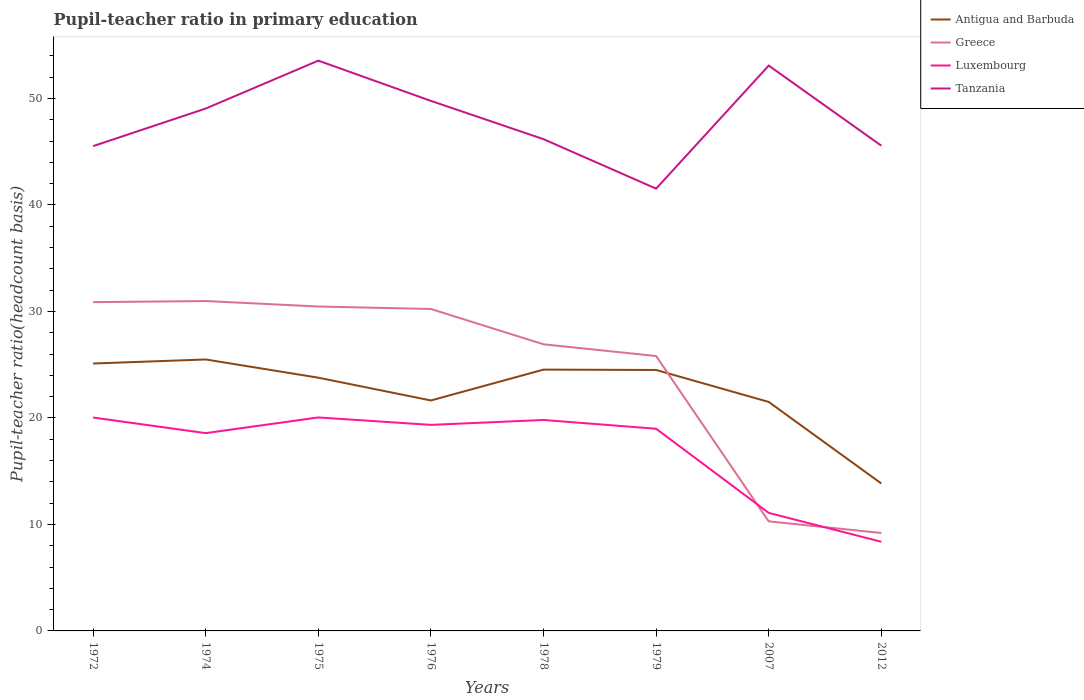Is the number of lines equal to the number of legend labels?
Your answer should be very brief. Yes. Across all years, what is the maximum pupil-teacher ratio in primary education in Greece?
Your answer should be very brief. 9.2. What is the total pupil-teacher ratio in primary education in Luxembourg in the graph?
Keep it short and to the point. 7.9. What is the difference between the highest and the second highest pupil-teacher ratio in primary education in Luxembourg?
Provide a short and direct response. 11.67. What is the difference between the highest and the lowest pupil-teacher ratio in primary education in Tanzania?
Your response must be concise. 4. How many lines are there?
Provide a succinct answer. 4. What is the difference between two consecutive major ticks on the Y-axis?
Offer a terse response. 10. Are the values on the major ticks of Y-axis written in scientific E-notation?
Your answer should be very brief. No. Does the graph contain any zero values?
Provide a succinct answer. No. How many legend labels are there?
Offer a terse response. 4. How are the legend labels stacked?
Provide a succinct answer. Vertical. What is the title of the graph?
Make the answer very short. Pupil-teacher ratio in primary education. Does "Timor-Leste" appear as one of the legend labels in the graph?
Your answer should be compact. No. What is the label or title of the Y-axis?
Offer a very short reply. Pupil-teacher ratio(headcount basis). What is the Pupil-teacher ratio(headcount basis) in Antigua and Barbuda in 1972?
Provide a succinct answer. 25.11. What is the Pupil-teacher ratio(headcount basis) in Greece in 1972?
Offer a terse response. 30.87. What is the Pupil-teacher ratio(headcount basis) in Luxembourg in 1972?
Provide a short and direct response. 20.04. What is the Pupil-teacher ratio(headcount basis) in Tanzania in 1972?
Keep it short and to the point. 45.53. What is the Pupil-teacher ratio(headcount basis) in Antigua and Barbuda in 1974?
Keep it short and to the point. 25.49. What is the Pupil-teacher ratio(headcount basis) of Greece in 1974?
Provide a succinct answer. 30.98. What is the Pupil-teacher ratio(headcount basis) in Luxembourg in 1974?
Provide a succinct answer. 18.57. What is the Pupil-teacher ratio(headcount basis) of Tanzania in 1974?
Ensure brevity in your answer.  49.05. What is the Pupil-teacher ratio(headcount basis) in Antigua and Barbuda in 1975?
Make the answer very short. 23.78. What is the Pupil-teacher ratio(headcount basis) of Greece in 1975?
Offer a terse response. 30.46. What is the Pupil-teacher ratio(headcount basis) in Luxembourg in 1975?
Offer a very short reply. 20.05. What is the Pupil-teacher ratio(headcount basis) of Tanzania in 1975?
Your answer should be very brief. 53.55. What is the Pupil-teacher ratio(headcount basis) in Antigua and Barbuda in 1976?
Ensure brevity in your answer.  21.64. What is the Pupil-teacher ratio(headcount basis) in Greece in 1976?
Offer a very short reply. 30.23. What is the Pupil-teacher ratio(headcount basis) in Luxembourg in 1976?
Keep it short and to the point. 19.35. What is the Pupil-teacher ratio(headcount basis) of Tanzania in 1976?
Provide a succinct answer. 49.77. What is the Pupil-teacher ratio(headcount basis) in Antigua and Barbuda in 1978?
Give a very brief answer. 24.54. What is the Pupil-teacher ratio(headcount basis) in Greece in 1978?
Provide a succinct answer. 26.91. What is the Pupil-teacher ratio(headcount basis) of Luxembourg in 1978?
Your response must be concise. 19.81. What is the Pupil-teacher ratio(headcount basis) in Tanzania in 1978?
Keep it short and to the point. 46.18. What is the Pupil-teacher ratio(headcount basis) of Antigua and Barbuda in 1979?
Offer a very short reply. 24.51. What is the Pupil-teacher ratio(headcount basis) of Greece in 1979?
Your response must be concise. 25.81. What is the Pupil-teacher ratio(headcount basis) in Luxembourg in 1979?
Offer a very short reply. 18.99. What is the Pupil-teacher ratio(headcount basis) in Tanzania in 1979?
Keep it short and to the point. 41.53. What is the Pupil-teacher ratio(headcount basis) of Antigua and Barbuda in 2007?
Ensure brevity in your answer.  21.5. What is the Pupil-teacher ratio(headcount basis) of Greece in 2007?
Ensure brevity in your answer.  10.29. What is the Pupil-teacher ratio(headcount basis) in Luxembourg in 2007?
Make the answer very short. 11.08. What is the Pupil-teacher ratio(headcount basis) in Tanzania in 2007?
Ensure brevity in your answer.  53.09. What is the Pupil-teacher ratio(headcount basis) of Antigua and Barbuda in 2012?
Your answer should be very brief. 13.85. What is the Pupil-teacher ratio(headcount basis) in Greece in 2012?
Keep it short and to the point. 9.2. What is the Pupil-teacher ratio(headcount basis) in Luxembourg in 2012?
Your response must be concise. 8.37. What is the Pupil-teacher ratio(headcount basis) in Tanzania in 2012?
Provide a short and direct response. 45.57. Across all years, what is the maximum Pupil-teacher ratio(headcount basis) in Antigua and Barbuda?
Offer a terse response. 25.49. Across all years, what is the maximum Pupil-teacher ratio(headcount basis) in Greece?
Ensure brevity in your answer.  30.98. Across all years, what is the maximum Pupil-teacher ratio(headcount basis) of Luxembourg?
Offer a terse response. 20.05. Across all years, what is the maximum Pupil-teacher ratio(headcount basis) of Tanzania?
Your response must be concise. 53.55. Across all years, what is the minimum Pupil-teacher ratio(headcount basis) in Antigua and Barbuda?
Offer a very short reply. 13.85. Across all years, what is the minimum Pupil-teacher ratio(headcount basis) in Greece?
Offer a terse response. 9.2. Across all years, what is the minimum Pupil-teacher ratio(headcount basis) in Luxembourg?
Offer a very short reply. 8.37. Across all years, what is the minimum Pupil-teacher ratio(headcount basis) of Tanzania?
Provide a short and direct response. 41.53. What is the total Pupil-teacher ratio(headcount basis) in Antigua and Barbuda in the graph?
Make the answer very short. 180.42. What is the total Pupil-teacher ratio(headcount basis) of Greece in the graph?
Offer a terse response. 194.76. What is the total Pupil-teacher ratio(headcount basis) of Luxembourg in the graph?
Offer a very short reply. 136.26. What is the total Pupil-teacher ratio(headcount basis) of Tanzania in the graph?
Your answer should be very brief. 384.27. What is the difference between the Pupil-teacher ratio(headcount basis) in Antigua and Barbuda in 1972 and that in 1974?
Ensure brevity in your answer.  -0.38. What is the difference between the Pupil-teacher ratio(headcount basis) in Greece in 1972 and that in 1974?
Your response must be concise. -0.1. What is the difference between the Pupil-teacher ratio(headcount basis) of Luxembourg in 1972 and that in 1974?
Your answer should be compact. 1.47. What is the difference between the Pupil-teacher ratio(headcount basis) of Tanzania in 1972 and that in 1974?
Offer a very short reply. -3.53. What is the difference between the Pupil-teacher ratio(headcount basis) of Antigua and Barbuda in 1972 and that in 1975?
Keep it short and to the point. 1.33. What is the difference between the Pupil-teacher ratio(headcount basis) in Greece in 1972 and that in 1975?
Offer a terse response. 0.41. What is the difference between the Pupil-teacher ratio(headcount basis) of Luxembourg in 1972 and that in 1975?
Offer a very short reply. -0.01. What is the difference between the Pupil-teacher ratio(headcount basis) in Tanzania in 1972 and that in 1975?
Make the answer very short. -8.03. What is the difference between the Pupil-teacher ratio(headcount basis) in Antigua and Barbuda in 1972 and that in 1976?
Make the answer very short. 3.47. What is the difference between the Pupil-teacher ratio(headcount basis) in Greece in 1972 and that in 1976?
Keep it short and to the point. 0.64. What is the difference between the Pupil-teacher ratio(headcount basis) in Luxembourg in 1972 and that in 1976?
Offer a very short reply. 0.69. What is the difference between the Pupil-teacher ratio(headcount basis) in Tanzania in 1972 and that in 1976?
Ensure brevity in your answer.  -4.25. What is the difference between the Pupil-teacher ratio(headcount basis) in Antigua and Barbuda in 1972 and that in 1978?
Provide a short and direct response. 0.57. What is the difference between the Pupil-teacher ratio(headcount basis) in Greece in 1972 and that in 1978?
Ensure brevity in your answer.  3.96. What is the difference between the Pupil-teacher ratio(headcount basis) in Luxembourg in 1972 and that in 1978?
Your response must be concise. 0.23. What is the difference between the Pupil-teacher ratio(headcount basis) of Tanzania in 1972 and that in 1978?
Provide a succinct answer. -0.65. What is the difference between the Pupil-teacher ratio(headcount basis) of Antigua and Barbuda in 1972 and that in 1979?
Your answer should be very brief. 0.6. What is the difference between the Pupil-teacher ratio(headcount basis) of Greece in 1972 and that in 1979?
Offer a very short reply. 5.06. What is the difference between the Pupil-teacher ratio(headcount basis) in Luxembourg in 1972 and that in 1979?
Provide a succinct answer. 1.05. What is the difference between the Pupil-teacher ratio(headcount basis) in Tanzania in 1972 and that in 1979?
Provide a succinct answer. 3.99. What is the difference between the Pupil-teacher ratio(headcount basis) of Antigua and Barbuda in 1972 and that in 2007?
Keep it short and to the point. 3.61. What is the difference between the Pupil-teacher ratio(headcount basis) of Greece in 1972 and that in 2007?
Your response must be concise. 20.59. What is the difference between the Pupil-teacher ratio(headcount basis) in Luxembourg in 1972 and that in 2007?
Provide a succinct answer. 8.96. What is the difference between the Pupil-teacher ratio(headcount basis) in Tanzania in 1972 and that in 2007?
Your answer should be very brief. -7.56. What is the difference between the Pupil-teacher ratio(headcount basis) in Antigua and Barbuda in 1972 and that in 2012?
Ensure brevity in your answer.  11.27. What is the difference between the Pupil-teacher ratio(headcount basis) in Greece in 1972 and that in 2012?
Offer a very short reply. 21.68. What is the difference between the Pupil-teacher ratio(headcount basis) of Luxembourg in 1972 and that in 2012?
Make the answer very short. 11.67. What is the difference between the Pupil-teacher ratio(headcount basis) in Tanzania in 1972 and that in 2012?
Your answer should be compact. -0.04. What is the difference between the Pupil-teacher ratio(headcount basis) in Antigua and Barbuda in 1974 and that in 1975?
Offer a terse response. 1.71. What is the difference between the Pupil-teacher ratio(headcount basis) of Greece in 1974 and that in 1975?
Keep it short and to the point. 0.51. What is the difference between the Pupil-teacher ratio(headcount basis) of Luxembourg in 1974 and that in 1975?
Provide a short and direct response. -1.47. What is the difference between the Pupil-teacher ratio(headcount basis) in Tanzania in 1974 and that in 1975?
Make the answer very short. -4.5. What is the difference between the Pupil-teacher ratio(headcount basis) in Antigua and Barbuda in 1974 and that in 1976?
Provide a succinct answer. 3.85. What is the difference between the Pupil-teacher ratio(headcount basis) of Greece in 1974 and that in 1976?
Your answer should be compact. 0.75. What is the difference between the Pupil-teacher ratio(headcount basis) of Luxembourg in 1974 and that in 1976?
Your answer should be compact. -0.78. What is the difference between the Pupil-teacher ratio(headcount basis) in Tanzania in 1974 and that in 1976?
Ensure brevity in your answer.  -0.72. What is the difference between the Pupil-teacher ratio(headcount basis) of Antigua and Barbuda in 1974 and that in 1978?
Make the answer very short. 0.95. What is the difference between the Pupil-teacher ratio(headcount basis) of Greece in 1974 and that in 1978?
Provide a short and direct response. 4.06. What is the difference between the Pupil-teacher ratio(headcount basis) in Luxembourg in 1974 and that in 1978?
Give a very brief answer. -1.24. What is the difference between the Pupil-teacher ratio(headcount basis) in Tanzania in 1974 and that in 1978?
Give a very brief answer. 2.88. What is the difference between the Pupil-teacher ratio(headcount basis) of Antigua and Barbuda in 1974 and that in 1979?
Your answer should be very brief. 0.99. What is the difference between the Pupil-teacher ratio(headcount basis) in Greece in 1974 and that in 1979?
Your response must be concise. 5.17. What is the difference between the Pupil-teacher ratio(headcount basis) in Luxembourg in 1974 and that in 1979?
Your response must be concise. -0.41. What is the difference between the Pupil-teacher ratio(headcount basis) of Tanzania in 1974 and that in 1979?
Your response must be concise. 7.52. What is the difference between the Pupil-teacher ratio(headcount basis) in Antigua and Barbuda in 1974 and that in 2007?
Your answer should be compact. 3.99. What is the difference between the Pupil-teacher ratio(headcount basis) in Greece in 1974 and that in 2007?
Give a very brief answer. 20.69. What is the difference between the Pupil-teacher ratio(headcount basis) in Luxembourg in 1974 and that in 2007?
Your response must be concise. 7.49. What is the difference between the Pupil-teacher ratio(headcount basis) of Tanzania in 1974 and that in 2007?
Keep it short and to the point. -4.03. What is the difference between the Pupil-teacher ratio(headcount basis) of Antigua and Barbuda in 1974 and that in 2012?
Provide a succinct answer. 11.65. What is the difference between the Pupil-teacher ratio(headcount basis) in Greece in 1974 and that in 2012?
Offer a terse response. 21.78. What is the difference between the Pupil-teacher ratio(headcount basis) in Luxembourg in 1974 and that in 2012?
Give a very brief answer. 10.2. What is the difference between the Pupil-teacher ratio(headcount basis) in Tanzania in 1974 and that in 2012?
Give a very brief answer. 3.49. What is the difference between the Pupil-teacher ratio(headcount basis) of Antigua and Barbuda in 1975 and that in 1976?
Offer a very short reply. 2.14. What is the difference between the Pupil-teacher ratio(headcount basis) of Greece in 1975 and that in 1976?
Offer a terse response. 0.23. What is the difference between the Pupil-teacher ratio(headcount basis) in Luxembourg in 1975 and that in 1976?
Your answer should be very brief. 0.7. What is the difference between the Pupil-teacher ratio(headcount basis) of Tanzania in 1975 and that in 1976?
Provide a succinct answer. 3.78. What is the difference between the Pupil-teacher ratio(headcount basis) of Antigua and Barbuda in 1975 and that in 1978?
Your answer should be very brief. -0.76. What is the difference between the Pupil-teacher ratio(headcount basis) of Greece in 1975 and that in 1978?
Provide a succinct answer. 3.55. What is the difference between the Pupil-teacher ratio(headcount basis) of Luxembourg in 1975 and that in 1978?
Give a very brief answer. 0.24. What is the difference between the Pupil-teacher ratio(headcount basis) in Tanzania in 1975 and that in 1978?
Your response must be concise. 7.37. What is the difference between the Pupil-teacher ratio(headcount basis) in Antigua and Barbuda in 1975 and that in 1979?
Offer a very short reply. -0.72. What is the difference between the Pupil-teacher ratio(headcount basis) in Greece in 1975 and that in 1979?
Keep it short and to the point. 4.65. What is the difference between the Pupil-teacher ratio(headcount basis) in Luxembourg in 1975 and that in 1979?
Keep it short and to the point. 1.06. What is the difference between the Pupil-teacher ratio(headcount basis) of Tanzania in 1975 and that in 1979?
Give a very brief answer. 12.02. What is the difference between the Pupil-teacher ratio(headcount basis) of Antigua and Barbuda in 1975 and that in 2007?
Give a very brief answer. 2.28. What is the difference between the Pupil-teacher ratio(headcount basis) in Greece in 1975 and that in 2007?
Your answer should be very brief. 20.17. What is the difference between the Pupil-teacher ratio(headcount basis) in Luxembourg in 1975 and that in 2007?
Your response must be concise. 8.96. What is the difference between the Pupil-teacher ratio(headcount basis) in Tanzania in 1975 and that in 2007?
Your answer should be compact. 0.47. What is the difference between the Pupil-teacher ratio(headcount basis) of Antigua and Barbuda in 1975 and that in 2012?
Ensure brevity in your answer.  9.94. What is the difference between the Pupil-teacher ratio(headcount basis) of Greece in 1975 and that in 2012?
Your answer should be compact. 21.27. What is the difference between the Pupil-teacher ratio(headcount basis) in Luxembourg in 1975 and that in 2012?
Provide a succinct answer. 11.67. What is the difference between the Pupil-teacher ratio(headcount basis) of Tanzania in 1975 and that in 2012?
Your answer should be compact. 7.99. What is the difference between the Pupil-teacher ratio(headcount basis) of Antigua and Barbuda in 1976 and that in 1978?
Your answer should be compact. -2.9. What is the difference between the Pupil-teacher ratio(headcount basis) of Greece in 1976 and that in 1978?
Provide a short and direct response. 3.32. What is the difference between the Pupil-teacher ratio(headcount basis) of Luxembourg in 1976 and that in 1978?
Your answer should be compact. -0.46. What is the difference between the Pupil-teacher ratio(headcount basis) of Tanzania in 1976 and that in 1978?
Ensure brevity in your answer.  3.59. What is the difference between the Pupil-teacher ratio(headcount basis) in Antigua and Barbuda in 1976 and that in 1979?
Ensure brevity in your answer.  -2.86. What is the difference between the Pupil-teacher ratio(headcount basis) in Greece in 1976 and that in 1979?
Your response must be concise. 4.42. What is the difference between the Pupil-teacher ratio(headcount basis) in Luxembourg in 1976 and that in 1979?
Provide a short and direct response. 0.36. What is the difference between the Pupil-teacher ratio(headcount basis) of Tanzania in 1976 and that in 1979?
Ensure brevity in your answer.  8.24. What is the difference between the Pupil-teacher ratio(headcount basis) in Antigua and Barbuda in 1976 and that in 2007?
Provide a short and direct response. 0.14. What is the difference between the Pupil-teacher ratio(headcount basis) of Greece in 1976 and that in 2007?
Give a very brief answer. 19.94. What is the difference between the Pupil-teacher ratio(headcount basis) in Luxembourg in 1976 and that in 2007?
Provide a succinct answer. 8.27. What is the difference between the Pupil-teacher ratio(headcount basis) of Tanzania in 1976 and that in 2007?
Offer a terse response. -3.31. What is the difference between the Pupil-teacher ratio(headcount basis) in Antigua and Barbuda in 1976 and that in 2012?
Your answer should be compact. 7.8. What is the difference between the Pupil-teacher ratio(headcount basis) of Greece in 1976 and that in 2012?
Provide a short and direct response. 21.03. What is the difference between the Pupil-teacher ratio(headcount basis) of Luxembourg in 1976 and that in 2012?
Make the answer very short. 10.98. What is the difference between the Pupil-teacher ratio(headcount basis) in Tanzania in 1976 and that in 2012?
Offer a very short reply. 4.21. What is the difference between the Pupil-teacher ratio(headcount basis) in Antigua and Barbuda in 1978 and that in 1979?
Your answer should be compact. 0.03. What is the difference between the Pupil-teacher ratio(headcount basis) in Greece in 1978 and that in 1979?
Your answer should be very brief. 1.1. What is the difference between the Pupil-teacher ratio(headcount basis) in Luxembourg in 1978 and that in 1979?
Your answer should be very brief. 0.82. What is the difference between the Pupil-teacher ratio(headcount basis) in Tanzania in 1978 and that in 1979?
Give a very brief answer. 4.65. What is the difference between the Pupil-teacher ratio(headcount basis) of Antigua and Barbuda in 1978 and that in 2007?
Provide a short and direct response. 3.03. What is the difference between the Pupil-teacher ratio(headcount basis) in Greece in 1978 and that in 2007?
Offer a very short reply. 16.63. What is the difference between the Pupil-teacher ratio(headcount basis) in Luxembourg in 1978 and that in 2007?
Your answer should be very brief. 8.72. What is the difference between the Pupil-teacher ratio(headcount basis) in Tanzania in 1978 and that in 2007?
Provide a short and direct response. -6.91. What is the difference between the Pupil-teacher ratio(headcount basis) in Antigua and Barbuda in 1978 and that in 2012?
Your answer should be very brief. 10.69. What is the difference between the Pupil-teacher ratio(headcount basis) in Greece in 1978 and that in 2012?
Provide a short and direct response. 17.72. What is the difference between the Pupil-teacher ratio(headcount basis) in Luxembourg in 1978 and that in 2012?
Ensure brevity in your answer.  11.44. What is the difference between the Pupil-teacher ratio(headcount basis) of Tanzania in 1978 and that in 2012?
Offer a terse response. 0.61. What is the difference between the Pupil-teacher ratio(headcount basis) in Antigua and Barbuda in 1979 and that in 2007?
Provide a succinct answer. 3. What is the difference between the Pupil-teacher ratio(headcount basis) of Greece in 1979 and that in 2007?
Offer a terse response. 15.52. What is the difference between the Pupil-teacher ratio(headcount basis) in Luxembourg in 1979 and that in 2007?
Your response must be concise. 7.9. What is the difference between the Pupil-teacher ratio(headcount basis) of Tanzania in 1979 and that in 2007?
Keep it short and to the point. -11.56. What is the difference between the Pupil-teacher ratio(headcount basis) of Antigua and Barbuda in 1979 and that in 2012?
Provide a short and direct response. 10.66. What is the difference between the Pupil-teacher ratio(headcount basis) of Greece in 1979 and that in 2012?
Ensure brevity in your answer.  16.61. What is the difference between the Pupil-teacher ratio(headcount basis) of Luxembourg in 1979 and that in 2012?
Provide a short and direct response. 10.61. What is the difference between the Pupil-teacher ratio(headcount basis) in Tanzania in 1979 and that in 2012?
Make the answer very short. -4.04. What is the difference between the Pupil-teacher ratio(headcount basis) in Antigua and Barbuda in 2007 and that in 2012?
Offer a terse response. 7.66. What is the difference between the Pupil-teacher ratio(headcount basis) of Greece in 2007 and that in 2012?
Provide a succinct answer. 1.09. What is the difference between the Pupil-teacher ratio(headcount basis) in Luxembourg in 2007 and that in 2012?
Offer a terse response. 2.71. What is the difference between the Pupil-teacher ratio(headcount basis) in Tanzania in 2007 and that in 2012?
Make the answer very short. 7.52. What is the difference between the Pupil-teacher ratio(headcount basis) of Antigua and Barbuda in 1972 and the Pupil-teacher ratio(headcount basis) of Greece in 1974?
Your answer should be very brief. -5.87. What is the difference between the Pupil-teacher ratio(headcount basis) of Antigua and Barbuda in 1972 and the Pupil-teacher ratio(headcount basis) of Luxembourg in 1974?
Give a very brief answer. 6.54. What is the difference between the Pupil-teacher ratio(headcount basis) of Antigua and Barbuda in 1972 and the Pupil-teacher ratio(headcount basis) of Tanzania in 1974?
Offer a very short reply. -23.94. What is the difference between the Pupil-teacher ratio(headcount basis) of Greece in 1972 and the Pupil-teacher ratio(headcount basis) of Luxembourg in 1974?
Give a very brief answer. 12.3. What is the difference between the Pupil-teacher ratio(headcount basis) of Greece in 1972 and the Pupil-teacher ratio(headcount basis) of Tanzania in 1974?
Provide a succinct answer. -18.18. What is the difference between the Pupil-teacher ratio(headcount basis) in Luxembourg in 1972 and the Pupil-teacher ratio(headcount basis) in Tanzania in 1974?
Keep it short and to the point. -29.02. What is the difference between the Pupil-teacher ratio(headcount basis) in Antigua and Barbuda in 1972 and the Pupil-teacher ratio(headcount basis) in Greece in 1975?
Provide a succinct answer. -5.35. What is the difference between the Pupil-teacher ratio(headcount basis) of Antigua and Barbuda in 1972 and the Pupil-teacher ratio(headcount basis) of Luxembourg in 1975?
Give a very brief answer. 5.06. What is the difference between the Pupil-teacher ratio(headcount basis) of Antigua and Barbuda in 1972 and the Pupil-teacher ratio(headcount basis) of Tanzania in 1975?
Offer a terse response. -28.44. What is the difference between the Pupil-teacher ratio(headcount basis) in Greece in 1972 and the Pupil-teacher ratio(headcount basis) in Luxembourg in 1975?
Give a very brief answer. 10.83. What is the difference between the Pupil-teacher ratio(headcount basis) of Greece in 1972 and the Pupil-teacher ratio(headcount basis) of Tanzania in 1975?
Your answer should be compact. -22.68. What is the difference between the Pupil-teacher ratio(headcount basis) in Luxembourg in 1972 and the Pupil-teacher ratio(headcount basis) in Tanzania in 1975?
Offer a terse response. -33.51. What is the difference between the Pupil-teacher ratio(headcount basis) in Antigua and Barbuda in 1972 and the Pupil-teacher ratio(headcount basis) in Greece in 1976?
Your response must be concise. -5.12. What is the difference between the Pupil-teacher ratio(headcount basis) in Antigua and Barbuda in 1972 and the Pupil-teacher ratio(headcount basis) in Luxembourg in 1976?
Your answer should be very brief. 5.76. What is the difference between the Pupil-teacher ratio(headcount basis) of Antigua and Barbuda in 1972 and the Pupil-teacher ratio(headcount basis) of Tanzania in 1976?
Provide a succinct answer. -24.66. What is the difference between the Pupil-teacher ratio(headcount basis) of Greece in 1972 and the Pupil-teacher ratio(headcount basis) of Luxembourg in 1976?
Make the answer very short. 11.53. What is the difference between the Pupil-teacher ratio(headcount basis) of Greece in 1972 and the Pupil-teacher ratio(headcount basis) of Tanzania in 1976?
Offer a terse response. -18.9. What is the difference between the Pupil-teacher ratio(headcount basis) in Luxembourg in 1972 and the Pupil-teacher ratio(headcount basis) in Tanzania in 1976?
Give a very brief answer. -29.73. What is the difference between the Pupil-teacher ratio(headcount basis) of Antigua and Barbuda in 1972 and the Pupil-teacher ratio(headcount basis) of Greece in 1978?
Your answer should be compact. -1.8. What is the difference between the Pupil-teacher ratio(headcount basis) of Antigua and Barbuda in 1972 and the Pupil-teacher ratio(headcount basis) of Luxembourg in 1978?
Your response must be concise. 5.3. What is the difference between the Pupil-teacher ratio(headcount basis) of Antigua and Barbuda in 1972 and the Pupil-teacher ratio(headcount basis) of Tanzania in 1978?
Keep it short and to the point. -21.07. What is the difference between the Pupil-teacher ratio(headcount basis) of Greece in 1972 and the Pupil-teacher ratio(headcount basis) of Luxembourg in 1978?
Provide a short and direct response. 11.07. What is the difference between the Pupil-teacher ratio(headcount basis) in Greece in 1972 and the Pupil-teacher ratio(headcount basis) in Tanzania in 1978?
Offer a very short reply. -15.3. What is the difference between the Pupil-teacher ratio(headcount basis) in Luxembourg in 1972 and the Pupil-teacher ratio(headcount basis) in Tanzania in 1978?
Provide a short and direct response. -26.14. What is the difference between the Pupil-teacher ratio(headcount basis) in Antigua and Barbuda in 1972 and the Pupil-teacher ratio(headcount basis) in Greece in 1979?
Your answer should be very brief. -0.7. What is the difference between the Pupil-teacher ratio(headcount basis) of Antigua and Barbuda in 1972 and the Pupil-teacher ratio(headcount basis) of Luxembourg in 1979?
Ensure brevity in your answer.  6.12. What is the difference between the Pupil-teacher ratio(headcount basis) of Antigua and Barbuda in 1972 and the Pupil-teacher ratio(headcount basis) of Tanzania in 1979?
Make the answer very short. -16.42. What is the difference between the Pupil-teacher ratio(headcount basis) in Greece in 1972 and the Pupil-teacher ratio(headcount basis) in Luxembourg in 1979?
Offer a very short reply. 11.89. What is the difference between the Pupil-teacher ratio(headcount basis) in Greece in 1972 and the Pupil-teacher ratio(headcount basis) in Tanzania in 1979?
Keep it short and to the point. -10.66. What is the difference between the Pupil-teacher ratio(headcount basis) of Luxembourg in 1972 and the Pupil-teacher ratio(headcount basis) of Tanzania in 1979?
Provide a short and direct response. -21.49. What is the difference between the Pupil-teacher ratio(headcount basis) in Antigua and Barbuda in 1972 and the Pupil-teacher ratio(headcount basis) in Greece in 2007?
Your response must be concise. 14.82. What is the difference between the Pupil-teacher ratio(headcount basis) in Antigua and Barbuda in 1972 and the Pupil-teacher ratio(headcount basis) in Luxembourg in 2007?
Provide a succinct answer. 14.03. What is the difference between the Pupil-teacher ratio(headcount basis) of Antigua and Barbuda in 1972 and the Pupil-teacher ratio(headcount basis) of Tanzania in 2007?
Your response must be concise. -27.98. What is the difference between the Pupil-teacher ratio(headcount basis) in Greece in 1972 and the Pupil-teacher ratio(headcount basis) in Luxembourg in 2007?
Offer a very short reply. 19.79. What is the difference between the Pupil-teacher ratio(headcount basis) in Greece in 1972 and the Pupil-teacher ratio(headcount basis) in Tanzania in 2007?
Offer a terse response. -22.21. What is the difference between the Pupil-teacher ratio(headcount basis) in Luxembourg in 1972 and the Pupil-teacher ratio(headcount basis) in Tanzania in 2007?
Offer a very short reply. -33.05. What is the difference between the Pupil-teacher ratio(headcount basis) in Antigua and Barbuda in 1972 and the Pupil-teacher ratio(headcount basis) in Greece in 2012?
Your answer should be very brief. 15.91. What is the difference between the Pupil-teacher ratio(headcount basis) of Antigua and Barbuda in 1972 and the Pupil-teacher ratio(headcount basis) of Luxembourg in 2012?
Your answer should be very brief. 16.74. What is the difference between the Pupil-teacher ratio(headcount basis) in Antigua and Barbuda in 1972 and the Pupil-teacher ratio(headcount basis) in Tanzania in 2012?
Give a very brief answer. -20.46. What is the difference between the Pupil-teacher ratio(headcount basis) in Greece in 1972 and the Pupil-teacher ratio(headcount basis) in Luxembourg in 2012?
Make the answer very short. 22.5. What is the difference between the Pupil-teacher ratio(headcount basis) in Greece in 1972 and the Pupil-teacher ratio(headcount basis) in Tanzania in 2012?
Make the answer very short. -14.69. What is the difference between the Pupil-teacher ratio(headcount basis) of Luxembourg in 1972 and the Pupil-teacher ratio(headcount basis) of Tanzania in 2012?
Offer a very short reply. -25.53. What is the difference between the Pupil-teacher ratio(headcount basis) in Antigua and Barbuda in 1974 and the Pupil-teacher ratio(headcount basis) in Greece in 1975?
Give a very brief answer. -4.97. What is the difference between the Pupil-teacher ratio(headcount basis) in Antigua and Barbuda in 1974 and the Pupil-teacher ratio(headcount basis) in Luxembourg in 1975?
Keep it short and to the point. 5.44. What is the difference between the Pupil-teacher ratio(headcount basis) of Antigua and Barbuda in 1974 and the Pupil-teacher ratio(headcount basis) of Tanzania in 1975?
Give a very brief answer. -28.06. What is the difference between the Pupil-teacher ratio(headcount basis) of Greece in 1974 and the Pupil-teacher ratio(headcount basis) of Luxembourg in 1975?
Your response must be concise. 10.93. What is the difference between the Pupil-teacher ratio(headcount basis) of Greece in 1974 and the Pupil-teacher ratio(headcount basis) of Tanzania in 1975?
Your answer should be very brief. -22.58. What is the difference between the Pupil-teacher ratio(headcount basis) in Luxembourg in 1974 and the Pupil-teacher ratio(headcount basis) in Tanzania in 1975?
Your response must be concise. -34.98. What is the difference between the Pupil-teacher ratio(headcount basis) in Antigua and Barbuda in 1974 and the Pupil-teacher ratio(headcount basis) in Greece in 1976?
Your answer should be very brief. -4.74. What is the difference between the Pupil-teacher ratio(headcount basis) of Antigua and Barbuda in 1974 and the Pupil-teacher ratio(headcount basis) of Luxembourg in 1976?
Your answer should be compact. 6.14. What is the difference between the Pupil-teacher ratio(headcount basis) in Antigua and Barbuda in 1974 and the Pupil-teacher ratio(headcount basis) in Tanzania in 1976?
Offer a terse response. -24.28. What is the difference between the Pupil-teacher ratio(headcount basis) in Greece in 1974 and the Pupil-teacher ratio(headcount basis) in Luxembourg in 1976?
Your answer should be very brief. 11.63. What is the difference between the Pupil-teacher ratio(headcount basis) of Greece in 1974 and the Pupil-teacher ratio(headcount basis) of Tanzania in 1976?
Give a very brief answer. -18.8. What is the difference between the Pupil-teacher ratio(headcount basis) in Luxembourg in 1974 and the Pupil-teacher ratio(headcount basis) in Tanzania in 1976?
Give a very brief answer. -31.2. What is the difference between the Pupil-teacher ratio(headcount basis) of Antigua and Barbuda in 1974 and the Pupil-teacher ratio(headcount basis) of Greece in 1978?
Make the answer very short. -1.42. What is the difference between the Pupil-teacher ratio(headcount basis) in Antigua and Barbuda in 1974 and the Pupil-teacher ratio(headcount basis) in Luxembourg in 1978?
Make the answer very short. 5.68. What is the difference between the Pupil-teacher ratio(headcount basis) of Antigua and Barbuda in 1974 and the Pupil-teacher ratio(headcount basis) of Tanzania in 1978?
Provide a short and direct response. -20.69. What is the difference between the Pupil-teacher ratio(headcount basis) in Greece in 1974 and the Pupil-teacher ratio(headcount basis) in Luxembourg in 1978?
Make the answer very short. 11.17. What is the difference between the Pupil-teacher ratio(headcount basis) in Greece in 1974 and the Pupil-teacher ratio(headcount basis) in Tanzania in 1978?
Your response must be concise. -15.2. What is the difference between the Pupil-teacher ratio(headcount basis) of Luxembourg in 1974 and the Pupil-teacher ratio(headcount basis) of Tanzania in 1978?
Offer a terse response. -27.61. What is the difference between the Pupil-teacher ratio(headcount basis) in Antigua and Barbuda in 1974 and the Pupil-teacher ratio(headcount basis) in Greece in 1979?
Your answer should be compact. -0.32. What is the difference between the Pupil-teacher ratio(headcount basis) of Antigua and Barbuda in 1974 and the Pupil-teacher ratio(headcount basis) of Luxembourg in 1979?
Your response must be concise. 6.51. What is the difference between the Pupil-teacher ratio(headcount basis) of Antigua and Barbuda in 1974 and the Pupil-teacher ratio(headcount basis) of Tanzania in 1979?
Give a very brief answer. -16.04. What is the difference between the Pupil-teacher ratio(headcount basis) of Greece in 1974 and the Pupil-teacher ratio(headcount basis) of Luxembourg in 1979?
Your answer should be compact. 11.99. What is the difference between the Pupil-teacher ratio(headcount basis) in Greece in 1974 and the Pupil-teacher ratio(headcount basis) in Tanzania in 1979?
Offer a very short reply. -10.55. What is the difference between the Pupil-teacher ratio(headcount basis) in Luxembourg in 1974 and the Pupil-teacher ratio(headcount basis) in Tanzania in 1979?
Your answer should be compact. -22.96. What is the difference between the Pupil-teacher ratio(headcount basis) in Antigua and Barbuda in 1974 and the Pupil-teacher ratio(headcount basis) in Greece in 2007?
Your answer should be compact. 15.2. What is the difference between the Pupil-teacher ratio(headcount basis) of Antigua and Barbuda in 1974 and the Pupil-teacher ratio(headcount basis) of Luxembourg in 2007?
Make the answer very short. 14.41. What is the difference between the Pupil-teacher ratio(headcount basis) in Antigua and Barbuda in 1974 and the Pupil-teacher ratio(headcount basis) in Tanzania in 2007?
Your answer should be very brief. -27.6. What is the difference between the Pupil-teacher ratio(headcount basis) in Greece in 1974 and the Pupil-teacher ratio(headcount basis) in Luxembourg in 2007?
Keep it short and to the point. 19.89. What is the difference between the Pupil-teacher ratio(headcount basis) in Greece in 1974 and the Pupil-teacher ratio(headcount basis) in Tanzania in 2007?
Make the answer very short. -22.11. What is the difference between the Pupil-teacher ratio(headcount basis) in Luxembourg in 1974 and the Pupil-teacher ratio(headcount basis) in Tanzania in 2007?
Make the answer very short. -34.51. What is the difference between the Pupil-teacher ratio(headcount basis) in Antigua and Barbuda in 1974 and the Pupil-teacher ratio(headcount basis) in Greece in 2012?
Provide a short and direct response. 16.29. What is the difference between the Pupil-teacher ratio(headcount basis) of Antigua and Barbuda in 1974 and the Pupil-teacher ratio(headcount basis) of Luxembourg in 2012?
Your answer should be compact. 17.12. What is the difference between the Pupil-teacher ratio(headcount basis) of Antigua and Barbuda in 1974 and the Pupil-teacher ratio(headcount basis) of Tanzania in 2012?
Ensure brevity in your answer.  -20.08. What is the difference between the Pupil-teacher ratio(headcount basis) in Greece in 1974 and the Pupil-teacher ratio(headcount basis) in Luxembourg in 2012?
Keep it short and to the point. 22.61. What is the difference between the Pupil-teacher ratio(headcount basis) of Greece in 1974 and the Pupil-teacher ratio(headcount basis) of Tanzania in 2012?
Keep it short and to the point. -14.59. What is the difference between the Pupil-teacher ratio(headcount basis) in Luxembourg in 1974 and the Pupil-teacher ratio(headcount basis) in Tanzania in 2012?
Provide a short and direct response. -26.99. What is the difference between the Pupil-teacher ratio(headcount basis) in Antigua and Barbuda in 1975 and the Pupil-teacher ratio(headcount basis) in Greece in 1976?
Offer a very short reply. -6.45. What is the difference between the Pupil-teacher ratio(headcount basis) of Antigua and Barbuda in 1975 and the Pupil-teacher ratio(headcount basis) of Luxembourg in 1976?
Provide a succinct answer. 4.43. What is the difference between the Pupil-teacher ratio(headcount basis) of Antigua and Barbuda in 1975 and the Pupil-teacher ratio(headcount basis) of Tanzania in 1976?
Your answer should be compact. -25.99. What is the difference between the Pupil-teacher ratio(headcount basis) of Greece in 1975 and the Pupil-teacher ratio(headcount basis) of Luxembourg in 1976?
Keep it short and to the point. 11.11. What is the difference between the Pupil-teacher ratio(headcount basis) in Greece in 1975 and the Pupil-teacher ratio(headcount basis) in Tanzania in 1976?
Provide a succinct answer. -19.31. What is the difference between the Pupil-teacher ratio(headcount basis) in Luxembourg in 1975 and the Pupil-teacher ratio(headcount basis) in Tanzania in 1976?
Give a very brief answer. -29.73. What is the difference between the Pupil-teacher ratio(headcount basis) in Antigua and Barbuda in 1975 and the Pupil-teacher ratio(headcount basis) in Greece in 1978?
Your answer should be compact. -3.13. What is the difference between the Pupil-teacher ratio(headcount basis) of Antigua and Barbuda in 1975 and the Pupil-teacher ratio(headcount basis) of Luxembourg in 1978?
Provide a short and direct response. 3.97. What is the difference between the Pupil-teacher ratio(headcount basis) of Antigua and Barbuda in 1975 and the Pupil-teacher ratio(headcount basis) of Tanzania in 1978?
Your answer should be very brief. -22.4. What is the difference between the Pupil-teacher ratio(headcount basis) of Greece in 1975 and the Pupil-teacher ratio(headcount basis) of Luxembourg in 1978?
Provide a succinct answer. 10.65. What is the difference between the Pupil-teacher ratio(headcount basis) of Greece in 1975 and the Pupil-teacher ratio(headcount basis) of Tanzania in 1978?
Make the answer very short. -15.72. What is the difference between the Pupil-teacher ratio(headcount basis) of Luxembourg in 1975 and the Pupil-teacher ratio(headcount basis) of Tanzania in 1978?
Give a very brief answer. -26.13. What is the difference between the Pupil-teacher ratio(headcount basis) of Antigua and Barbuda in 1975 and the Pupil-teacher ratio(headcount basis) of Greece in 1979?
Ensure brevity in your answer.  -2.03. What is the difference between the Pupil-teacher ratio(headcount basis) in Antigua and Barbuda in 1975 and the Pupil-teacher ratio(headcount basis) in Luxembourg in 1979?
Your answer should be compact. 4.79. What is the difference between the Pupil-teacher ratio(headcount basis) in Antigua and Barbuda in 1975 and the Pupil-teacher ratio(headcount basis) in Tanzania in 1979?
Provide a succinct answer. -17.75. What is the difference between the Pupil-teacher ratio(headcount basis) of Greece in 1975 and the Pupil-teacher ratio(headcount basis) of Luxembourg in 1979?
Provide a succinct answer. 11.48. What is the difference between the Pupil-teacher ratio(headcount basis) of Greece in 1975 and the Pupil-teacher ratio(headcount basis) of Tanzania in 1979?
Keep it short and to the point. -11.07. What is the difference between the Pupil-teacher ratio(headcount basis) of Luxembourg in 1975 and the Pupil-teacher ratio(headcount basis) of Tanzania in 1979?
Provide a short and direct response. -21.48. What is the difference between the Pupil-teacher ratio(headcount basis) of Antigua and Barbuda in 1975 and the Pupil-teacher ratio(headcount basis) of Greece in 2007?
Provide a succinct answer. 13.49. What is the difference between the Pupil-teacher ratio(headcount basis) of Antigua and Barbuda in 1975 and the Pupil-teacher ratio(headcount basis) of Luxembourg in 2007?
Your answer should be compact. 12.7. What is the difference between the Pupil-teacher ratio(headcount basis) in Antigua and Barbuda in 1975 and the Pupil-teacher ratio(headcount basis) in Tanzania in 2007?
Give a very brief answer. -29.31. What is the difference between the Pupil-teacher ratio(headcount basis) in Greece in 1975 and the Pupil-teacher ratio(headcount basis) in Luxembourg in 2007?
Give a very brief answer. 19.38. What is the difference between the Pupil-teacher ratio(headcount basis) of Greece in 1975 and the Pupil-teacher ratio(headcount basis) of Tanzania in 2007?
Ensure brevity in your answer.  -22.62. What is the difference between the Pupil-teacher ratio(headcount basis) of Luxembourg in 1975 and the Pupil-teacher ratio(headcount basis) of Tanzania in 2007?
Provide a succinct answer. -33.04. What is the difference between the Pupil-teacher ratio(headcount basis) in Antigua and Barbuda in 1975 and the Pupil-teacher ratio(headcount basis) in Greece in 2012?
Make the answer very short. 14.58. What is the difference between the Pupil-teacher ratio(headcount basis) in Antigua and Barbuda in 1975 and the Pupil-teacher ratio(headcount basis) in Luxembourg in 2012?
Your answer should be compact. 15.41. What is the difference between the Pupil-teacher ratio(headcount basis) of Antigua and Barbuda in 1975 and the Pupil-teacher ratio(headcount basis) of Tanzania in 2012?
Provide a succinct answer. -21.79. What is the difference between the Pupil-teacher ratio(headcount basis) in Greece in 1975 and the Pupil-teacher ratio(headcount basis) in Luxembourg in 2012?
Your answer should be compact. 22.09. What is the difference between the Pupil-teacher ratio(headcount basis) in Greece in 1975 and the Pupil-teacher ratio(headcount basis) in Tanzania in 2012?
Offer a terse response. -15.1. What is the difference between the Pupil-teacher ratio(headcount basis) in Luxembourg in 1975 and the Pupil-teacher ratio(headcount basis) in Tanzania in 2012?
Keep it short and to the point. -25.52. What is the difference between the Pupil-teacher ratio(headcount basis) of Antigua and Barbuda in 1976 and the Pupil-teacher ratio(headcount basis) of Greece in 1978?
Provide a succinct answer. -5.27. What is the difference between the Pupil-teacher ratio(headcount basis) of Antigua and Barbuda in 1976 and the Pupil-teacher ratio(headcount basis) of Luxembourg in 1978?
Your response must be concise. 1.83. What is the difference between the Pupil-teacher ratio(headcount basis) of Antigua and Barbuda in 1976 and the Pupil-teacher ratio(headcount basis) of Tanzania in 1978?
Provide a succinct answer. -24.54. What is the difference between the Pupil-teacher ratio(headcount basis) in Greece in 1976 and the Pupil-teacher ratio(headcount basis) in Luxembourg in 1978?
Offer a terse response. 10.42. What is the difference between the Pupil-teacher ratio(headcount basis) of Greece in 1976 and the Pupil-teacher ratio(headcount basis) of Tanzania in 1978?
Give a very brief answer. -15.95. What is the difference between the Pupil-teacher ratio(headcount basis) in Luxembourg in 1976 and the Pupil-teacher ratio(headcount basis) in Tanzania in 1978?
Provide a succinct answer. -26.83. What is the difference between the Pupil-teacher ratio(headcount basis) in Antigua and Barbuda in 1976 and the Pupil-teacher ratio(headcount basis) in Greece in 1979?
Offer a very short reply. -4.17. What is the difference between the Pupil-teacher ratio(headcount basis) in Antigua and Barbuda in 1976 and the Pupil-teacher ratio(headcount basis) in Luxembourg in 1979?
Your answer should be very brief. 2.66. What is the difference between the Pupil-teacher ratio(headcount basis) of Antigua and Barbuda in 1976 and the Pupil-teacher ratio(headcount basis) of Tanzania in 1979?
Ensure brevity in your answer.  -19.89. What is the difference between the Pupil-teacher ratio(headcount basis) of Greece in 1976 and the Pupil-teacher ratio(headcount basis) of Luxembourg in 1979?
Your answer should be compact. 11.25. What is the difference between the Pupil-teacher ratio(headcount basis) of Greece in 1976 and the Pupil-teacher ratio(headcount basis) of Tanzania in 1979?
Offer a terse response. -11.3. What is the difference between the Pupil-teacher ratio(headcount basis) in Luxembourg in 1976 and the Pupil-teacher ratio(headcount basis) in Tanzania in 1979?
Make the answer very short. -22.18. What is the difference between the Pupil-teacher ratio(headcount basis) in Antigua and Barbuda in 1976 and the Pupil-teacher ratio(headcount basis) in Greece in 2007?
Provide a short and direct response. 11.35. What is the difference between the Pupil-teacher ratio(headcount basis) in Antigua and Barbuda in 1976 and the Pupil-teacher ratio(headcount basis) in Luxembourg in 2007?
Keep it short and to the point. 10.56. What is the difference between the Pupil-teacher ratio(headcount basis) in Antigua and Barbuda in 1976 and the Pupil-teacher ratio(headcount basis) in Tanzania in 2007?
Make the answer very short. -31.45. What is the difference between the Pupil-teacher ratio(headcount basis) of Greece in 1976 and the Pupil-teacher ratio(headcount basis) of Luxembourg in 2007?
Your answer should be very brief. 19.15. What is the difference between the Pupil-teacher ratio(headcount basis) in Greece in 1976 and the Pupil-teacher ratio(headcount basis) in Tanzania in 2007?
Provide a short and direct response. -22.86. What is the difference between the Pupil-teacher ratio(headcount basis) of Luxembourg in 1976 and the Pupil-teacher ratio(headcount basis) of Tanzania in 2007?
Offer a very short reply. -33.74. What is the difference between the Pupil-teacher ratio(headcount basis) of Antigua and Barbuda in 1976 and the Pupil-teacher ratio(headcount basis) of Greece in 2012?
Ensure brevity in your answer.  12.44. What is the difference between the Pupil-teacher ratio(headcount basis) of Antigua and Barbuda in 1976 and the Pupil-teacher ratio(headcount basis) of Luxembourg in 2012?
Offer a terse response. 13.27. What is the difference between the Pupil-teacher ratio(headcount basis) in Antigua and Barbuda in 1976 and the Pupil-teacher ratio(headcount basis) in Tanzania in 2012?
Provide a succinct answer. -23.93. What is the difference between the Pupil-teacher ratio(headcount basis) in Greece in 1976 and the Pupil-teacher ratio(headcount basis) in Luxembourg in 2012?
Your answer should be compact. 21.86. What is the difference between the Pupil-teacher ratio(headcount basis) of Greece in 1976 and the Pupil-teacher ratio(headcount basis) of Tanzania in 2012?
Ensure brevity in your answer.  -15.34. What is the difference between the Pupil-teacher ratio(headcount basis) in Luxembourg in 1976 and the Pupil-teacher ratio(headcount basis) in Tanzania in 2012?
Keep it short and to the point. -26.22. What is the difference between the Pupil-teacher ratio(headcount basis) in Antigua and Barbuda in 1978 and the Pupil-teacher ratio(headcount basis) in Greece in 1979?
Offer a terse response. -1.27. What is the difference between the Pupil-teacher ratio(headcount basis) in Antigua and Barbuda in 1978 and the Pupil-teacher ratio(headcount basis) in Luxembourg in 1979?
Your answer should be compact. 5.55. What is the difference between the Pupil-teacher ratio(headcount basis) of Antigua and Barbuda in 1978 and the Pupil-teacher ratio(headcount basis) of Tanzania in 1979?
Provide a short and direct response. -16.99. What is the difference between the Pupil-teacher ratio(headcount basis) of Greece in 1978 and the Pupil-teacher ratio(headcount basis) of Luxembourg in 1979?
Offer a very short reply. 7.93. What is the difference between the Pupil-teacher ratio(headcount basis) in Greece in 1978 and the Pupil-teacher ratio(headcount basis) in Tanzania in 1979?
Offer a terse response. -14.62. What is the difference between the Pupil-teacher ratio(headcount basis) in Luxembourg in 1978 and the Pupil-teacher ratio(headcount basis) in Tanzania in 1979?
Provide a short and direct response. -21.72. What is the difference between the Pupil-teacher ratio(headcount basis) of Antigua and Barbuda in 1978 and the Pupil-teacher ratio(headcount basis) of Greece in 2007?
Your answer should be very brief. 14.25. What is the difference between the Pupil-teacher ratio(headcount basis) of Antigua and Barbuda in 1978 and the Pupil-teacher ratio(headcount basis) of Luxembourg in 2007?
Offer a very short reply. 13.45. What is the difference between the Pupil-teacher ratio(headcount basis) of Antigua and Barbuda in 1978 and the Pupil-teacher ratio(headcount basis) of Tanzania in 2007?
Keep it short and to the point. -28.55. What is the difference between the Pupil-teacher ratio(headcount basis) of Greece in 1978 and the Pupil-teacher ratio(headcount basis) of Luxembourg in 2007?
Your response must be concise. 15.83. What is the difference between the Pupil-teacher ratio(headcount basis) in Greece in 1978 and the Pupil-teacher ratio(headcount basis) in Tanzania in 2007?
Your answer should be very brief. -26.17. What is the difference between the Pupil-teacher ratio(headcount basis) in Luxembourg in 1978 and the Pupil-teacher ratio(headcount basis) in Tanzania in 2007?
Offer a terse response. -33.28. What is the difference between the Pupil-teacher ratio(headcount basis) in Antigua and Barbuda in 1978 and the Pupil-teacher ratio(headcount basis) in Greece in 2012?
Your response must be concise. 15.34. What is the difference between the Pupil-teacher ratio(headcount basis) in Antigua and Barbuda in 1978 and the Pupil-teacher ratio(headcount basis) in Luxembourg in 2012?
Provide a succinct answer. 16.17. What is the difference between the Pupil-teacher ratio(headcount basis) of Antigua and Barbuda in 1978 and the Pupil-teacher ratio(headcount basis) of Tanzania in 2012?
Your answer should be compact. -21.03. What is the difference between the Pupil-teacher ratio(headcount basis) of Greece in 1978 and the Pupil-teacher ratio(headcount basis) of Luxembourg in 2012?
Provide a succinct answer. 18.54. What is the difference between the Pupil-teacher ratio(headcount basis) in Greece in 1978 and the Pupil-teacher ratio(headcount basis) in Tanzania in 2012?
Make the answer very short. -18.65. What is the difference between the Pupil-teacher ratio(headcount basis) in Luxembourg in 1978 and the Pupil-teacher ratio(headcount basis) in Tanzania in 2012?
Offer a terse response. -25.76. What is the difference between the Pupil-teacher ratio(headcount basis) of Antigua and Barbuda in 1979 and the Pupil-teacher ratio(headcount basis) of Greece in 2007?
Provide a short and direct response. 14.22. What is the difference between the Pupil-teacher ratio(headcount basis) of Antigua and Barbuda in 1979 and the Pupil-teacher ratio(headcount basis) of Luxembourg in 2007?
Offer a very short reply. 13.42. What is the difference between the Pupil-teacher ratio(headcount basis) in Antigua and Barbuda in 1979 and the Pupil-teacher ratio(headcount basis) in Tanzania in 2007?
Offer a terse response. -28.58. What is the difference between the Pupil-teacher ratio(headcount basis) in Greece in 1979 and the Pupil-teacher ratio(headcount basis) in Luxembourg in 2007?
Give a very brief answer. 14.73. What is the difference between the Pupil-teacher ratio(headcount basis) in Greece in 1979 and the Pupil-teacher ratio(headcount basis) in Tanzania in 2007?
Ensure brevity in your answer.  -27.28. What is the difference between the Pupil-teacher ratio(headcount basis) in Luxembourg in 1979 and the Pupil-teacher ratio(headcount basis) in Tanzania in 2007?
Your answer should be compact. -34.1. What is the difference between the Pupil-teacher ratio(headcount basis) in Antigua and Barbuda in 1979 and the Pupil-teacher ratio(headcount basis) in Greece in 2012?
Offer a very short reply. 15.31. What is the difference between the Pupil-teacher ratio(headcount basis) in Antigua and Barbuda in 1979 and the Pupil-teacher ratio(headcount basis) in Luxembourg in 2012?
Offer a very short reply. 16.13. What is the difference between the Pupil-teacher ratio(headcount basis) of Antigua and Barbuda in 1979 and the Pupil-teacher ratio(headcount basis) of Tanzania in 2012?
Offer a terse response. -21.06. What is the difference between the Pupil-teacher ratio(headcount basis) of Greece in 1979 and the Pupil-teacher ratio(headcount basis) of Luxembourg in 2012?
Your answer should be compact. 17.44. What is the difference between the Pupil-teacher ratio(headcount basis) of Greece in 1979 and the Pupil-teacher ratio(headcount basis) of Tanzania in 2012?
Offer a very short reply. -19.76. What is the difference between the Pupil-teacher ratio(headcount basis) of Luxembourg in 1979 and the Pupil-teacher ratio(headcount basis) of Tanzania in 2012?
Keep it short and to the point. -26.58. What is the difference between the Pupil-teacher ratio(headcount basis) in Antigua and Barbuda in 2007 and the Pupil-teacher ratio(headcount basis) in Greece in 2012?
Ensure brevity in your answer.  12.31. What is the difference between the Pupil-teacher ratio(headcount basis) of Antigua and Barbuda in 2007 and the Pupil-teacher ratio(headcount basis) of Luxembourg in 2012?
Your response must be concise. 13.13. What is the difference between the Pupil-teacher ratio(headcount basis) in Antigua and Barbuda in 2007 and the Pupil-teacher ratio(headcount basis) in Tanzania in 2012?
Offer a terse response. -24.06. What is the difference between the Pupil-teacher ratio(headcount basis) in Greece in 2007 and the Pupil-teacher ratio(headcount basis) in Luxembourg in 2012?
Your answer should be very brief. 1.92. What is the difference between the Pupil-teacher ratio(headcount basis) of Greece in 2007 and the Pupil-teacher ratio(headcount basis) of Tanzania in 2012?
Offer a terse response. -35.28. What is the difference between the Pupil-teacher ratio(headcount basis) in Luxembourg in 2007 and the Pupil-teacher ratio(headcount basis) in Tanzania in 2012?
Your answer should be compact. -34.48. What is the average Pupil-teacher ratio(headcount basis) of Antigua and Barbuda per year?
Keep it short and to the point. 22.55. What is the average Pupil-teacher ratio(headcount basis) in Greece per year?
Provide a succinct answer. 24.34. What is the average Pupil-teacher ratio(headcount basis) of Luxembourg per year?
Your answer should be compact. 17.03. What is the average Pupil-teacher ratio(headcount basis) in Tanzania per year?
Your answer should be compact. 48.03. In the year 1972, what is the difference between the Pupil-teacher ratio(headcount basis) in Antigua and Barbuda and Pupil-teacher ratio(headcount basis) in Greece?
Keep it short and to the point. -5.76. In the year 1972, what is the difference between the Pupil-teacher ratio(headcount basis) in Antigua and Barbuda and Pupil-teacher ratio(headcount basis) in Luxembourg?
Your answer should be very brief. 5.07. In the year 1972, what is the difference between the Pupil-teacher ratio(headcount basis) in Antigua and Barbuda and Pupil-teacher ratio(headcount basis) in Tanzania?
Ensure brevity in your answer.  -20.41. In the year 1972, what is the difference between the Pupil-teacher ratio(headcount basis) in Greece and Pupil-teacher ratio(headcount basis) in Luxembourg?
Your answer should be very brief. 10.84. In the year 1972, what is the difference between the Pupil-teacher ratio(headcount basis) in Greece and Pupil-teacher ratio(headcount basis) in Tanzania?
Offer a very short reply. -14.65. In the year 1972, what is the difference between the Pupil-teacher ratio(headcount basis) of Luxembourg and Pupil-teacher ratio(headcount basis) of Tanzania?
Your response must be concise. -25.49. In the year 1974, what is the difference between the Pupil-teacher ratio(headcount basis) in Antigua and Barbuda and Pupil-teacher ratio(headcount basis) in Greece?
Ensure brevity in your answer.  -5.49. In the year 1974, what is the difference between the Pupil-teacher ratio(headcount basis) in Antigua and Barbuda and Pupil-teacher ratio(headcount basis) in Luxembourg?
Keep it short and to the point. 6.92. In the year 1974, what is the difference between the Pupil-teacher ratio(headcount basis) in Antigua and Barbuda and Pupil-teacher ratio(headcount basis) in Tanzania?
Your answer should be compact. -23.56. In the year 1974, what is the difference between the Pupil-teacher ratio(headcount basis) of Greece and Pupil-teacher ratio(headcount basis) of Luxembourg?
Give a very brief answer. 12.4. In the year 1974, what is the difference between the Pupil-teacher ratio(headcount basis) of Greece and Pupil-teacher ratio(headcount basis) of Tanzania?
Ensure brevity in your answer.  -18.08. In the year 1974, what is the difference between the Pupil-teacher ratio(headcount basis) of Luxembourg and Pupil-teacher ratio(headcount basis) of Tanzania?
Keep it short and to the point. -30.48. In the year 1975, what is the difference between the Pupil-teacher ratio(headcount basis) in Antigua and Barbuda and Pupil-teacher ratio(headcount basis) in Greece?
Provide a succinct answer. -6.68. In the year 1975, what is the difference between the Pupil-teacher ratio(headcount basis) in Antigua and Barbuda and Pupil-teacher ratio(headcount basis) in Luxembourg?
Your answer should be compact. 3.73. In the year 1975, what is the difference between the Pupil-teacher ratio(headcount basis) of Antigua and Barbuda and Pupil-teacher ratio(headcount basis) of Tanzania?
Make the answer very short. -29.77. In the year 1975, what is the difference between the Pupil-teacher ratio(headcount basis) in Greece and Pupil-teacher ratio(headcount basis) in Luxembourg?
Make the answer very short. 10.42. In the year 1975, what is the difference between the Pupil-teacher ratio(headcount basis) of Greece and Pupil-teacher ratio(headcount basis) of Tanzania?
Provide a short and direct response. -23.09. In the year 1975, what is the difference between the Pupil-teacher ratio(headcount basis) of Luxembourg and Pupil-teacher ratio(headcount basis) of Tanzania?
Offer a very short reply. -33.51. In the year 1976, what is the difference between the Pupil-teacher ratio(headcount basis) in Antigua and Barbuda and Pupil-teacher ratio(headcount basis) in Greece?
Your response must be concise. -8.59. In the year 1976, what is the difference between the Pupil-teacher ratio(headcount basis) in Antigua and Barbuda and Pupil-teacher ratio(headcount basis) in Luxembourg?
Offer a terse response. 2.29. In the year 1976, what is the difference between the Pupil-teacher ratio(headcount basis) of Antigua and Barbuda and Pupil-teacher ratio(headcount basis) of Tanzania?
Your answer should be very brief. -28.13. In the year 1976, what is the difference between the Pupil-teacher ratio(headcount basis) in Greece and Pupil-teacher ratio(headcount basis) in Luxembourg?
Provide a short and direct response. 10.88. In the year 1976, what is the difference between the Pupil-teacher ratio(headcount basis) of Greece and Pupil-teacher ratio(headcount basis) of Tanzania?
Your answer should be very brief. -19.54. In the year 1976, what is the difference between the Pupil-teacher ratio(headcount basis) of Luxembourg and Pupil-teacher ratio(headcount basis) of Tanzania?
Provide a short and direct response. -30.42. In the year 1978, what is the difference between the Pupil-teacher ratio(headcount basis) of Antigua and Barbuda and Pupil-teacher ratio(headcount basis) of Greece?
Your answer should be compact. -2.38. In the year 1978, what is the difference between the Pupil-teacher ratio(headcount basis) of Antigua and Barbuda and Pupil-teacher ratio(headcount basis) of Luxembourg?
Offer a terse response. 4.73. In the year 1978, what is the difference between the Pupil-teacher ratio(headcount basis) of Antigua and Barbuda and Pupil-teacher ratio(headcount basis) of Tanzania?
Your answer should be compact. -21.64. In the year 1978, what is the difference between the Pupil-teacher ratio(headcount basis) in Greece and Pupil-teacher ratio(headcount basis) in Luxembourg?
Offer a very short reply. 7.11. In the year 1978, what is the difference between the Pupil-teacher ratio(headcount basis) in Greece and Pupil-teacher ratio(headcount basis) in Tanzania?
Provide a short and direct response. -19.26. In the year 1978, what is the difference between the Pupil-teacher ratio(headcount basis) in Luxembourg and Pupil-teacher ratio(headcount basis) in Tanzania?
Keep it short and to the point. -26.37. In the year 1979, what is the difference between the Pupil-teacher ratio(headcount basis) in Antigua and Barbuda and Pupil-teacher ratio(headcount basis) in Greece?
Give a very brief answer. -1.31. In the year 1979, what is the difference between the Pupil-teacher ratio(headcount basis) of Antigua and Barbuda and Pupil-teacher ratio(headcount basis) of Luxembourg?
Keep it short and to the point. 5.52. In the year 1979, what is the difference between the Pupil-teacher ratio(headcount basis) in Antigua and Barbuda and Pupil-teacher ratio(headcount basis) in Tanzania?
Offer a terse response. -17.03. In the year 1979, what is the difference between the Pupil-teacher ratio(headcount basis) in Greece and Pupil-teacher ratio(headcount basis) in Luxembourg?
Provide a succinct answer. 6.83. In the year 1979, what is the difference between the Pupil-teacher ratio(headcount basis) in Greece and Pupil-teacher ratio(headcount basis) in Tanzania?
Provide a short and direct response. -15.72. In the year 1979, what is the difference between the Pupil-teacher ratio(headcount basis) in Luxembourg and Pupil-teacher ratio(headcount basis) in Tanzania?
Make the answer very short. -22.55. In the year 2007, what is the difference between the Pupil-teacher ratio(headcount basis) of Antigua and Barbuda and Pupil-teacher ratio(headcount basis) of Greece?
Make the answer very short. 11.21. In the year 2007, what is the difference between the Pupil-teacher ratio(headcount basis) of Antigua and Barbuda and Pupil-teacher ratio(headcount basis) of Luxembourg?
Offer a very short reply. 10.42. In the year 2007, what is the difference between the Pupil-teacher ratio(headcount basis) of Antigua and Barbuda and Pupil-teacher ratio(headcount basis) of Tanzania?
Offer a very short reply. -31.58. In the year 2007, what is the difference between the Pupil-teacher ratio(headcount basis) of Greece and Pupil-teacher ratio(headcount basis) of Luxembourg?
Offer a terse response. -0.8. In the year 2007, what is the difference between the Pupil-teacher ratio(headcount basis) of Greece and Pupil-teacher ratio(headcount basis) of Tanzania?
Your answer should be very brief. -42.8. In the year 2007, what is the difference between the Pupil-teacher ratio(headcount basis) of Luxembourg and Pupil-teacher ratio(headcount basis) of Tanzania?
Provide a succinct answer. -42. In the year 2012, what is the difference between the Pupil-teacher ratio(headcount basis) in Antigua and Barbuda and Pupil-teacher ratio(headcount basis) in Greece?
Give a very brief answer. 4.65. In the year 2012, what is the difference between the Pupil-teacher ratio(headcount basis) of Antigua and Barbuda and Pupil-teacher ratio(headcount basis) of Luxembourg?
Make the answer very short. 5.47. In the year 2012, what is the difference between the Pupil-teacher ratio(headcount basis) in Antigua and Barbuda and Pupil-teacher ratio(headcount basis) in Tanzania?
Your answer should be very brief. -31.72. In the year 2012, what is the difference between the Pupil-teacher ratio(headcount basis) in Greece and Pupil-teacher ratio(headcount basis) in Luxembourg?
Provide a short and direct response. 0.83. In the year 2012, what is the difference between the Pupil-teacher ratio(headcount basis) of Greece and Pupil-teacher ratio(headcount basis) of Tanzania?
Provide a succinct answer. -36.37. In the year 2012, what is the difference between the Pupil-teacher ratio(headcount basis) in Luxembourg and Pupil-teacher ratio(headcount basis) in Tanzania?
Offer a very short reply. -37.2. What is the ratio of the Pupil-teacher ratio(headcount basis) in Antigua and Barbuda in 1972 to that in 1974?
Your answer should be compact. 0.99. What is the ratio of the Pupil-teacher ratio(headcount basis) in Greece in 1972 to that in 1974?
Your answer should be very brief. 1. What is the ratio of the Pupil-teacher ratio(headcount basis) of Luxembourg in 1972 to that in 1974?
Provide a short and direct response. 1.08. What is the ratio of the Pupil-teacher ratio(headcount basis) in Tanzania in 1972 to that in 1974?
Your response must be concise. 0.93. What is the ratio of the Pupil-teacher ratio(headcount basis) in Antigua and Barbuda in 1972 to that in 1975?
Ensure brevity in your answer.  1.06. What is the ratio of the Pupil-teacher ratio(headcount basis) in Greece in 1972 to that in 1975?
Keep it short and to the point. 1.01. What is the ratio of the Pupil-teacher ratio(headcount basis) in Tanzania in 1972 to that in 1975?
Your answer should be very brief. 0.85. What is the ratio of the Pupil-teacher ratio(headcount basis) of Antigua and Barbuda in 1972 to that in 1976?
Offer a very short reply. 1.16. What is the ratio of the Pupil-teacher ratio(headcount basis) of Greece in 1972 to that in 1976?
Ensure brevity in your answer.  1.02. What is the ratio of the Pupil-teacher ratio(headcount basis) in Luxembourg in 1972 to that in 1976?
Make the answer very short. 1.04. What is the ratio of the Pupil-teacher ratio(headcount basis) in Tanzania in 1972 to that in 1976?
Ensure brevity in your answer.  0.91. What is the ratio of the Pupil-teacher ratio(headcount basis) in Antigua and Barbuda in 1972 to that in 1978?
Your answer should be compact. 1.02. What is the ratio of the Pupil-teacher ratio(headcount basis) of Greece in 1972 to that in 1978?
Your response must be concise. 1.15. What is the ratio of the Pupil-teacher ratio(headcount basis) of Luxembourg in 1972 to that in 1978?
Provide a succinct answer. 1.01. What is the ratio of the Pupil-teacher ratio(headcount basis) of Tanzania in 1972 to that in 1978?
Your answer should be compact. 0.99. What is the ratio of the Pupil-teacher ratio(headcount basis) in Antigua and Barbuda in 1972 to that in 1979?
Keep it short and to the point. 1.02. What is the ratio of the Pupil-teacher ratio(headcount basis) in Greece in 1972 to that in 1979?
Your answer should be compact. 1.2. What is the ratio of the Pupil-teacher ratio(headcount basis) in Luxembourg in 1972 to that in 1979?
Offer a terse response. 1.06. What is the ratio of the Pupil-teacher ratio(headcount basis) in Tanzania in 1972 to that in 1979?
Provide a short and direct response. 1.1. What is the ratio of the Pupil-teacher ratio(headcount basis) of Antigua and Barbuda in 1972 to that in 2007?
Offer a very short reply. 1.17. What is the ratio of the Pupil-teacher ratio(headcount basis) of Greece in 1972 to that in 2007?
Offer a very short reply. 3. What is the ratio of the Pupil-teacher ratio(headcount basis) of Luxembourg in 1972 to that in 2007?
Provide a succinct answer. 1.81. What is the ratio of the Pupil-teacher ratio(headcount basis) in Tanzania in 1972 to that in 2007?
Your answer should be compact. 0.86. What is the ratio of the Pupil-teacher ratio(headcount basis) in Antigua and Barbuda in 1972 to that in 2012?
Give a very brief answer. 1.81. What is the ratio of the Pupil-teacher ratio(headcount basis) of Greece in 1972 to that in 2012?
Your answer should be compact. 3.36. What is the ratio of the Pupil-teacher ratio(headcount basis) of Luxembourg in 1972 to that in 2012?
Give a very brief answer. 2.39. What is the ratio of the Pupil-teacher ratio(headcount basis) in Antigua and Barbuda in 1974 to that in 1975?
Provide a succinct answer. 1.07. What is the ratio of the Pupil-teacher ratio(headcount basis) of Greece in 1974 to that in 1975?
Your answer should be compact. 1.02. What is the ratio of the Pupil-teacher ratio(headcount basis) of Luxembourg in 1974 to that in 1975?
Provide a succinct answer. 0.93. What is the ratio of the Pupil-teacher ratio(headcount basis) in Tanzania in 1974 to that in 1975?
Make the answer very short. 0.92. What is the ratio of the Pupil-teacher ratio(headcount basis) in Antigua and Barbuda in 1974 to that in 1976?
Offer a very short reply. 1.18. What is the ratio of the Pupil-teacher ratio(headcount basis) of Greece in 1974 to that in 1976?
Ensure brevity in your answer.  1.02. What is the ratio of the Pupil-teacher ratio(headcount basis) of Luxembourg in 1974 to that in 1976?
Make the answer very short. 0.96. What is the ratio of the Pupil-teacher ratio(headcount basis) of Tanzania in 1974 to that in 1976?
Make the answer very short. 0.99. What is the ratio of the Pupil-teacher ratio(headcount basis) of Antigua and Barbuda in 1974 to that in 1978?
Give a very brief answer. 1.04. What is the ratio of the Pupil-teacher ratio(headcount basis) in Greece in 1974 to that in 1978?
Your response must be concise. 1.15. What is the ratio of the Pupil-teacher ratio(headcount basis) in Luxembourg in 1974 to that in 1978?
Give a very brief answer. 0.94. What is the ratio of the Pupil-teacher ratio(headcount basis) in Tanzania in 1974 to that in 1978?
Offer a very short reply. 1.06. What is the ratio of the Pupil-teacher ratio(headcount basis) in Antigua and Barbuda in 1974 to that in 1979?
Your answer should be compact. 1.04. What is the ratio of the Pupil-teacher ratio(headcount basis) in Greece in 1974 to that in 1979?
Your response must be concise. 1.2. What is the ratio of the Pupil-teacher ratio(headcount basis) in Luxembourg in 1974 to that in 1979?
Give a very brief answer. 0.98. What is the ratio of the Pupil-teacher ratio(headcount basis) in Tanzania in 1974 to that in 1979?
Your answer should be compact. 1.18. What is the ratio of the Pupil-teacher ratio(headcount basis) of Antigua and Barbuda in 1974 to that in 2007?
Offer a terse response. 1.19. What is the ratio of the Pupil-teacher ratio(headcount basis) of Greece in 1974 to that in 2007?
Your answer should be compact. 3.01. What is the ratio of the Pupil-teacher ratio(headcount basis) of Luxembourg in 1974 to that in 2007?
Offer a very short reply. 1.68. What is the ratio of the Pupil-teacher ratio(headcount basis) in Tanzania in 1974 to that in 2007?
Give a very brief answer. 0.92. What is the ratio of the Pupil-teacher ratio(headcount basis) of Antigua and Barbuda in 1974 to that in 2012?
Give a very brief answer. 1.84. What is the ratio of the Pupil-teacher ratio(headcount basis) in Greece in 1974 to that in 2012?
Your answer should be very brief. 3.37. What is the ratio of the Pupil-teacher ratio(headcount basis) in Luxembourg in 1974 to that in 2012?
Give a very brief answer. 2.22. What is the ratio of the Pupil-teacher ratio(headcount basis) in Tanzania in 1974 to that in 2012?
Keep it short and to the point. 1.08. What is the ratio of the Pupil-teacher ratio(headcount basis) in Antigua and Barbuda in 1975 to that in 1976?
Offer a terse response. 1.1. What is the ratio of the Pupil-teacher ratio(headcount basis) in Greece in 1975 to that in 1976?
Offer a terse response. 1.01. What is the ratio of the Pupil-teacher ratio(headcount basis) in Luxembourg in 1975 to that in 1976?
Your answer should be very brief. 1.04. What is the ratio of the Pupil-teacher ratio(headcount basis) of Tanzania in 1975 to that in 1976?
Ensure brevity in your answer.  1.08. What is the ratio of the Pupil-teacher ratio(headcount basis) in Antigua and Barbuda in 1975 to that in 1978?
Ensure brevity in your answer.  0.97. What is the ratio of the Pupil-teacher ratio(headcount basis) of Greece in 1975 to that in 1978?
Offer a terse response. 1.13. What is the ratio of the Pupil-teacher ratio(headcount basis) in Tanzania in 1975 to that in 1978?
Your answer should be compact. 1.16. What is the ratio of the Pupil-teacher ratio(headcount basis) in Antigua and Barbuda in 1975 to that in 1979?
Keep it short and to the point. 0.97. What is the ratio of the Pupil-teacher ratio(headcount basis) in Greece in 1975 to that in 1979?
Ensure brevity in your answer.  1.18. What is the ratio of the Pupil-teacher ratio(headcount basis) of Luxembourg in 1975 to that in 1979?
Your answer should be compact. 1.06. What is the ratio of the Pupil-teacher ratio(headcount basis) of Tanzania in 1975 to that in 1979?
Offer a terse response. 1.29. What is the ratio of the Pupil-teacher ratio(headcount basis) in Antigua and Barbuda in 1975 to that in 2007?
Your answer should be compact. 1.11. What is the ratio of the Pupil-teacher ratio(headcount basis) of Greece in 1975 to that in 2007?
Provide a short and direct response. 2.96. What is the ratio of the Pupil-teacher ratio(headcount basis) of Luxembourg in 1975 to that in 2007?
Your answer should be compact. 1.81. What is the ratio of the Pupil-teacher ratio(headcount basis) of Tanzania in 1975 to that in 2007?
Ensure brevity in your answer.  1.01. What is the ratio of the Pupil-teacher ratio(headcount basis) in Antigua and Barbuda in 1975 to that in 2012?
Ensure brevity in your answer.  1.72. What is the ratio of the Pupil-teacher ratio(headcount basis) of Greece in 1975 to that in 2012?
Your answer should be compact. 3.31. What is the ratio of the Pupil-teacher ratio(headcount basis) in Luxembourg in 1975 to that in 2012?
Provide a succinct answer. 2.39. What is the ratio of the Pupil-teacher ratio(headcount basis) of Tanzania in 1975 to that in 2012?
Provide a succinct answer. 1.18. What is the ratio of the Pupil-teacher ratio(headcount basis) of Antigua and Barbuda in 1976 to that in 1978?
Your answer should be very brief. 0.88. What is the ratio of the Pupil-teacher ratio(headcount basis) in Greece in 1976 to that in 1978?
Your answer should be very brief. 1.12. What is the ratio of the Pupil-teacher ratio(headcount basis) in Luxembourg in 1976 to that in 1978?
Provide a succinct answer. 0.98. What is the ratio of the Pupil-teacher ratio(headcount basis) in Tanzania in 1976 to that in 1978?
Ensure brevity in your answer.  1.08. What is the ratio of the Pupil-teacher ratio(headcount basis) in Antigua and Barbuda in 1976 to that in 1979?
Keep it short and to the point. 0.88. What is the ratio of the Pupil-teacher ratio(headcount basis) of Greece in 1976 to that in 1979?
Ensure brevity in your answer.  1.17. What is the ratio of the Pupil-teacher ratio(headcount basis) of Luxembourg in 1976 to that in 1979?
Your answer should be very brief. 1.02. What is the ratio of the Pupil-teacher ratio(headcount basis) of Tanzania in 1976 to that in 1979?
Your answer should be compact. 1.2. What is the ratio of the Pupil-teacher ratio(headcount basis) of Antigua and Barbuda in 1976 to that in 2007?
Your answer should be very brief. 1.01. What is the ratio of the Pupil-teacher ratio(headcount basis) in Greece in 1976 to that in 2007?
Your response must be concise. 2.94. What is the ratio of the Pupil-teacher ratio(headcount basis) in Luxembourg in 1976 to that in 2007?
Your answer should be compact. 1.75. What is the ratio of the Pupil-teacher ratio(headcount basis) in Tanzania in 1976 to that in 2007?
Offer a terse response. 0.94. What is the ratio of the Pupil-teacher ratio(headcount basis) of Antigua and Barbuda in 1976 to that in 2012?
Provide a short and direct response. 1.56. What is the ratio of the Pupil-teacher ratio(headcount basis) of Greece in 1976 to that in 2012?
Your answer should be compact. 3.29. What is the ratio of the Pupil-teacher ratio(headcount basis) of Luxembourg in 1976 to that in 2012?
Give a very brief answer. 2.31. What is the ratio of the Pupil-teacher ratio(headcount basis) in Tanzania in 1976 to that in 2012?
Offer a very short reply. 1.09. What is the ratio of the Pupil-teacher ratio(headcount basis) in Greece in 1978 to that in 1979?
Make the answer very short. 1.04. What is the ratio of the Pupil-teacher ratio(headcount basis) of Luxembourg in 1978 to that in 1979?
Your answer should be compact. 1.04. What is the ratio of the Pupil-teacher ratio(headcount basis) in Tanzania in 1978 to that in 1979?
Provide a succinct answer. 1.11. What is the ratio of the Pupil-teacher ratio(headcount basis) of Antigua and Barbuda in 1978 to that in 2007?
Provide a short and direct response. 1.14. What is the ratio of the Pupil-teacher ratio(headcount basis) in Greece in 1978 to that in 2007?
Ensure brevity in your answer.  2.62. What is the ratio of the Pupil-teacher ratio(headcount basis) in Luxembourg in 1978 to that in 2007?
Offer a terse response. 1.79. What is the ratio of the Pupil-teacher ratio(headcount basis) in Tanzania in 1978 to that in 2007?
Offer a terse response. 0.87. What is the ratio of the Pupil-teacher ratio(headcount basis) in Antigua and Barbuda in 1978 to that in 2012?
Your answer should be very brief. 1.77. What is the ratio of the Pupil-teacher ratio(headcount basis) of Greece in 1978 to that in 2012?
Your answer should be very brief. 2.93. What is the ratio of the Pupil-teacher ratio(headcount basis) in Luxembourg in 1978 to that in 2012?
Provide a short and direct response. 2.37. What is the ratio of the Pupil-teacher ratio(headcount basis) of Tanzania in 1978 to that in 2012?
Offer a terse response. 1.01. What is the ratio of the Pupil-teacher ratio(headcount basis) in Antigua and Barbuda in 1979 to that in 2007?
Provide a short and direct response. 1.14. What is the ratio of the Pupil-teacher ratio(headcount basis) of Greece in 1979 to that in 2007?
Your answer should be very brief. 2.51. What is the ratio of the Pupil-teacher ratio(headcount basis) of Luxembourg in 1979 to that in 2007?
Give a very brief answer. 1.71. What is the ratio of the Pupil-teacher ratio(headcount basis) in Tanzania in 1979 to that in 2007?
Your answer should be compact. 0.78. What is the ratio of the Pupil-teacher ratio(headcount basis) of Antigua and Barbuda in 1979 to that in 2012?
Offer a very short reply. 1.77. What is the ratio of the Pupil-teacher ratio(headcount basis) in Greece in 1979 to that in 2012?
Offer a very short reply. 2.81. What is the ratio of the Pupil-teacher ratio(headcount basis) in Luxembourg in 1979 to that in 2012?
Give a very brief answer. 2.27. What is the ratio of the Pupil-teacher ratio(headcount basis) in Tanzania in 1979 to that in 2012?
Your answer should be compact. 0.91. What is the ratio of the Pupil-teacher ratio(headcount basis) in Antigua and Barbuda in 2007 to that in 2012?
Keep it short and to the point. 1.55. What is the ratio of the Pupil-teacher ratio(headcount basis) of Greece in 2007 to that in 2012?
Keep it short and to the point. 1.12. What is the ratio of the Pupil-teacher ratio(headcount basis) in Luxembourg in 2007 to that in 2012?
Your answer should be very brief. 1.32. What is the ratio of the Pupil-teacher ratio(headcount basis) of Tanzania in 2007 to that in 2012?
Ensure brevity in your answer.  1.17. What is the difference between the highest and the second highest Pupil-teacher ratio(headcount basis) in Antigua and Barbuda?
Offer a very short reply. 0.38. What is the difference between the highest and the second highest Pupil-teacher ratio(headcount basis) of Greece?
Offer a very short reply. 0.1. What is the difference between the highest and the second highest Pupil-teacher ratio(headcount basis) of Luxembourg?
Ensure brevity in your answer.  0.01. What is the difference between the highest and the second highest Pupil-teacher ratio(headcount basis) in Tanzania?
Give a very brief answer. 0.47. What is the difference between the highest and the lowest Pupil-teacher ratio(headcount basis) in Antigua and Barbuda?
Your answer should be compact. 11.65. What is the difference between the highest and the lowest Pupil-teacher ratio(headcount basis) in Greece?
Offer a terse response. 21.78. What is the difference between the highest and the lowest Pupil-teacher ratio(headcount basis) of Luxembourg?
Your answer should be very brief. 11.67. What is the difference between the highest and the lowest Pupil-teacher ratio(headcount basis) in Tanzania?
Your response must be concise. 12.02. 